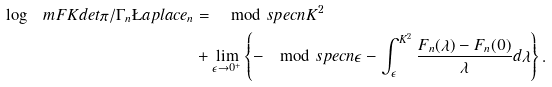<formula> <loc_0><loc_0><loc_500><loc_500>\log \ m F K d e t { \pi / \Gamma _ { n } } \L a p l a c e _ { n } & = \mod s p e c { n } { K ^ { 2 } } \\ & + \lim _ { \epsilon \rightarrow 0 ^ { + } } \left \{ - \mod s p e c { n } { \epsilon } - { \int _ { \epsilon } ^ { K ^ { 2 } } \frac { F _ { n } ( \lambda ) - F _ { n } ( 0 ) } { \lambda } d \lambda } \right \} .</formula> 